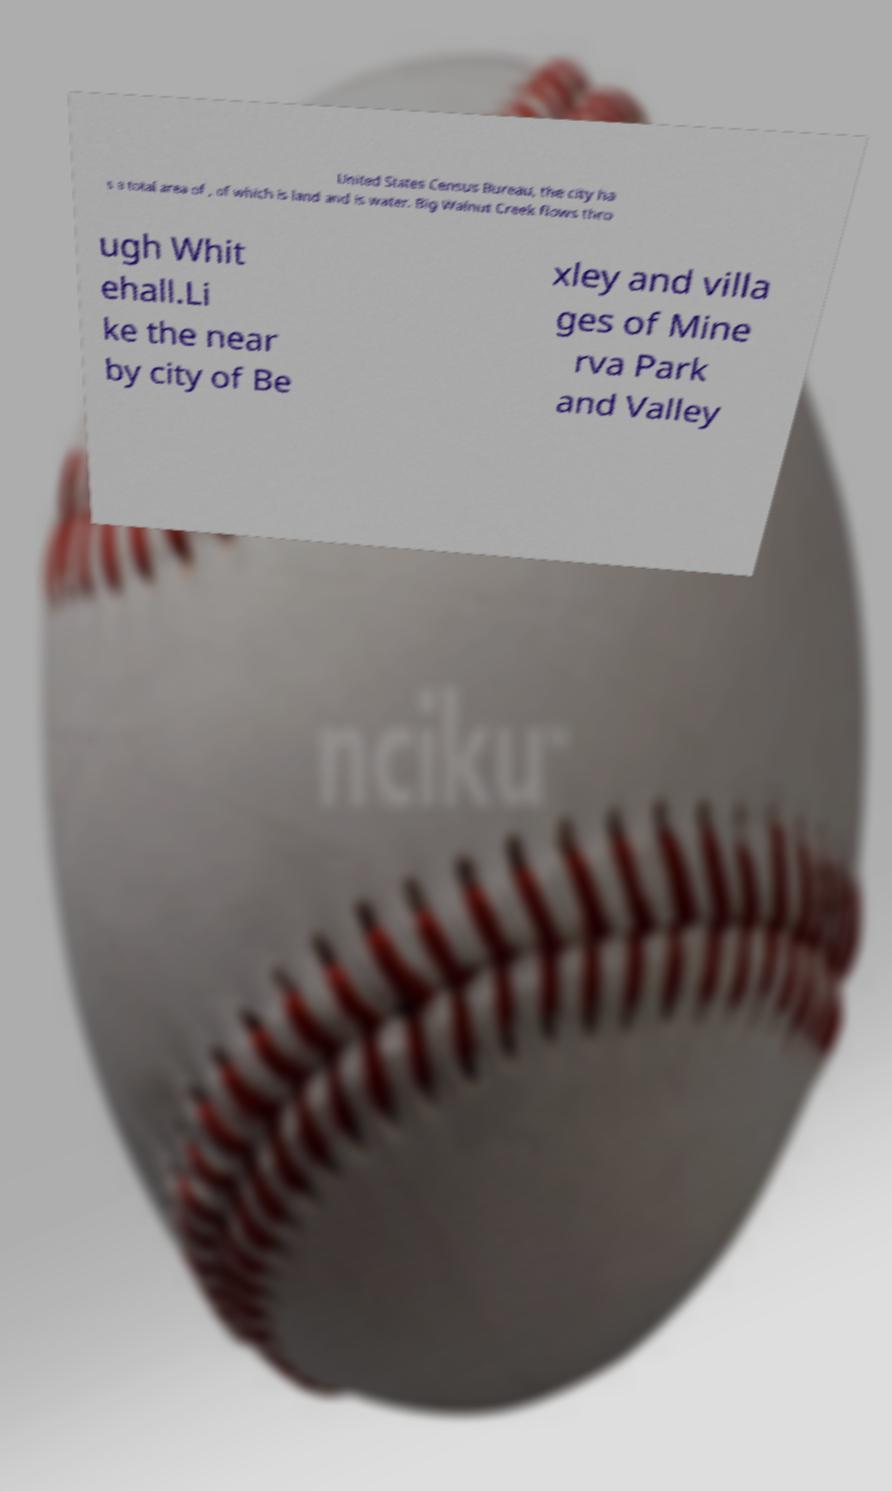There's text embedded in this image that I need extracted. Can you transcribe it verbatim? United States Census Bureau, the city ha s a total area of , of which is land and is water. Big Walnut Creek flows thro ugh Whit ehall.Li ke the near by city of Be xley and villa ges of Mine rva Park and Valley 